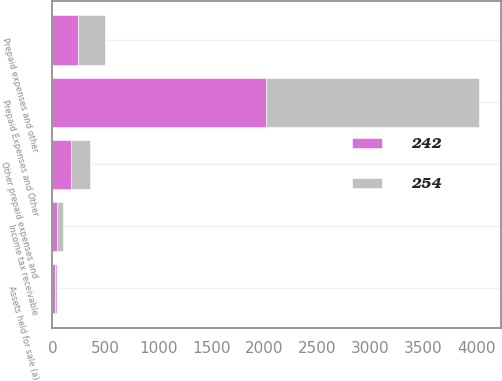<chart> <loc_0><loc_0><loc_500><loc_500><stacked_bar_chart><ecel><fcel>Prepaid Expenses and Other<fcel>Income tax receivable<fcel>Assets held for sale (a)<fcel>Other prepaid expenses and<fcel>Prepaid expenses and other<nl><fcel>242<fcel>2015<fcel>41<fcel>28<fcel>173<fcel>242<nl><fcel>254<fcel>2014<fcel>55<fcel>14<fcel>185<fcel>254<nl></chart> 